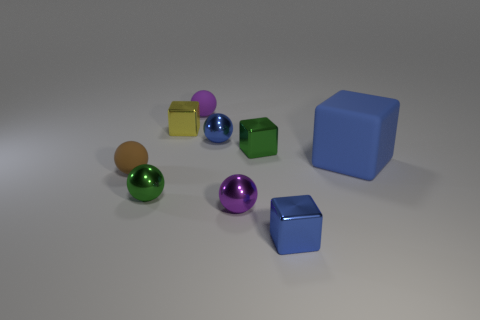What number of objects are in front of the brown matte ball and behind the tiny purple metal ball?
Offer a very short reply. 1. Are there any metallic balls in front of the small blue metallic thing behind the purple sphere that is to the right of the tiny purple rubber thing?
Make the answer very short. Yes. What shape is the brown object that is the same size as the yellow metallic object?
Provide a short and direct response. Sphere. Are there any metallic blocks of the same color as the big thing?
Make the answer very short. Yes. Is the big blue matte object the same shape as the purple matte object?
Ensure brevity in your answer.  No. How many large objects are yellow things or green blocks?
Give a very brief answer. 0. There is a tiny sphere that is the same material as the brown object; what is its color?
Your answer should be compact. Purple. What number of tiny spheres have the same material as the brown object?
Make the answer very short. 1. There is a purple thing in front of the tiny brown rubber sphere; is it the same size as the purple ball behind the blue metal ball?
Provide a short and direct response. Yes. There is a purple thing to the left of the small blue object that is behind the large blue matte cube; what is it made of?
Offer a very short reply. Rubber. 